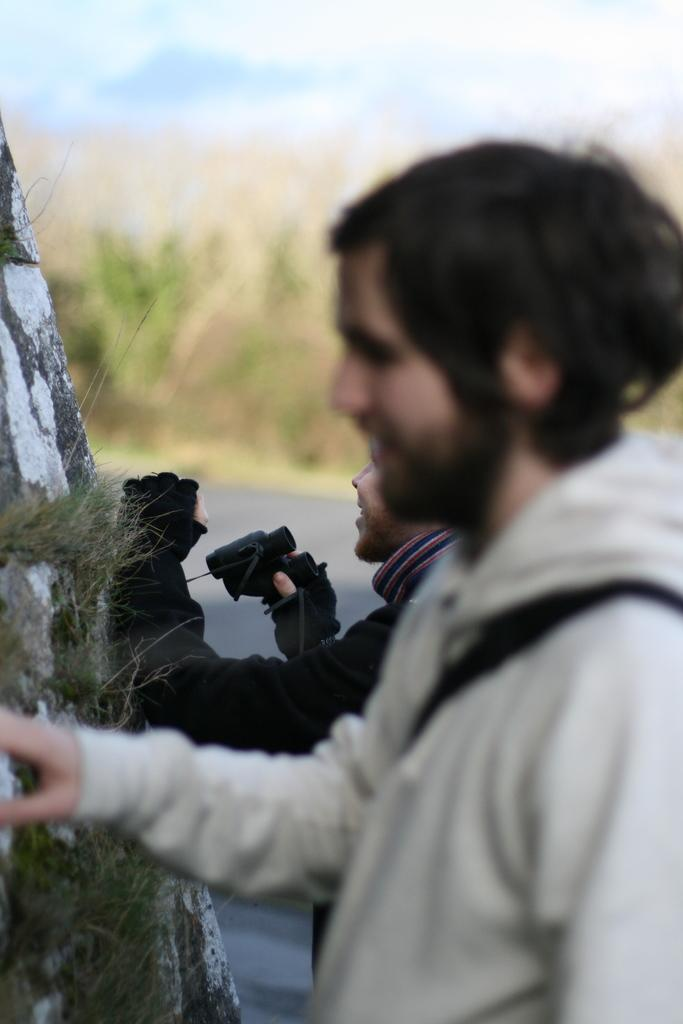What is the person in the image doing with their hand? The person in the image has their hand on a rock. What is the other person in the image holding? The other person in the image is holding binoculars. Can you describe the background of the image? The background of the image is blurred. What color are the dinosaurs in the image? There are no dinosaurs present in the image. What is the front of the image showing? The provided facts do not specify a front or any particular direction in the image. 